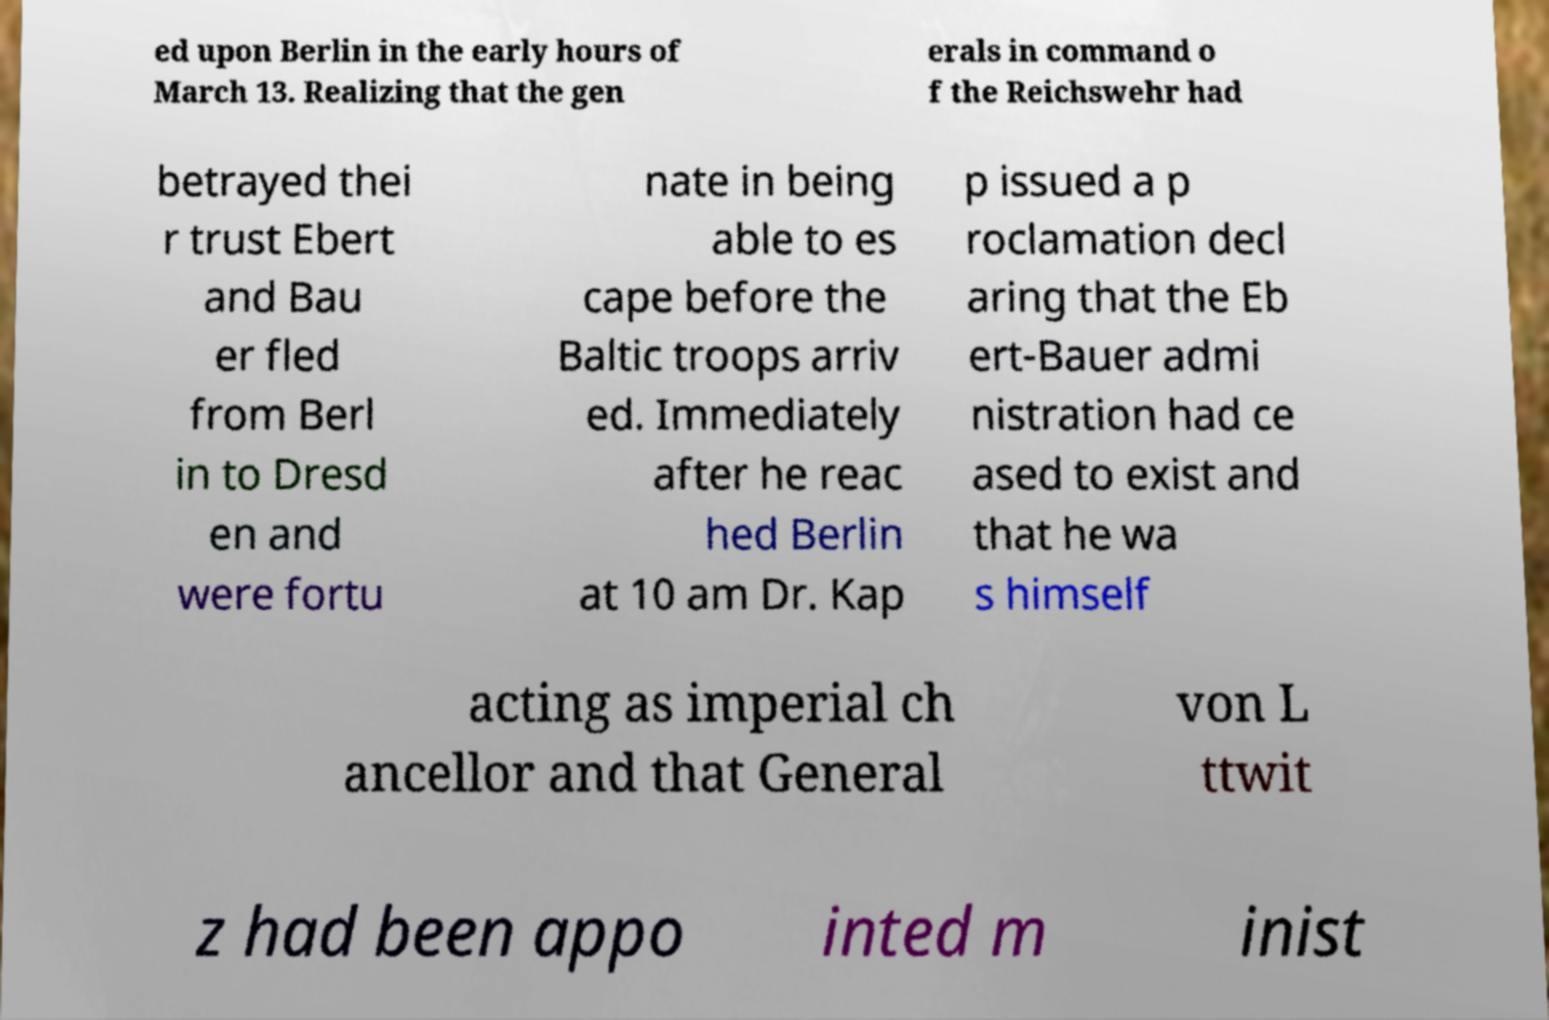Could you extract and type out the text from this image? ed upon Berlin in the early hours of March 13. Realizing that the gen erals in command o f the Reichswehr had betrayed thei r trust Ebert and Bau er fled from Berl in to Dresd en and were fortu nate in being able to es cape before the Baltic troops arriv ed. Immediately after he reac hed Berlin at 10 am Dr. Kap p issued a p roclamation decl aring that the Eb ert-Bauer admi nistration had ce ased to exist and that he wa s himself acting as imperial ch ancellor and that General von L ttwit z had been appo inted m inist 